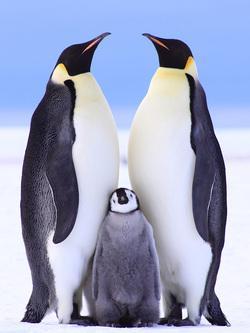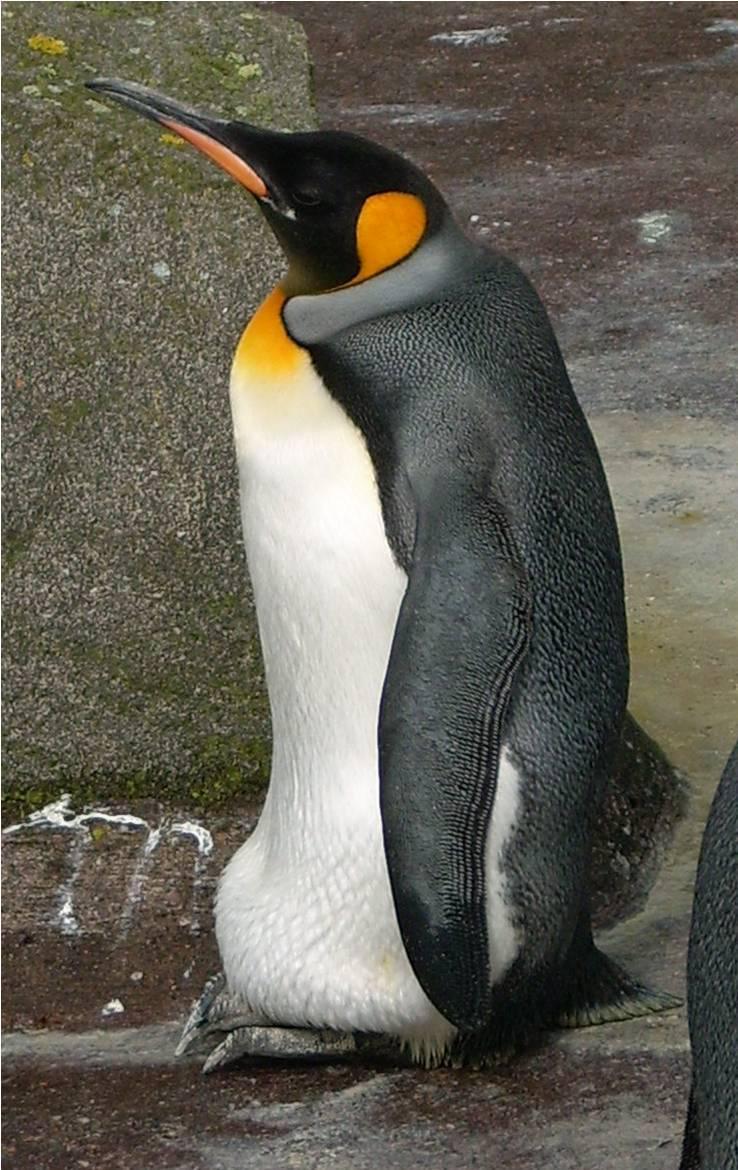The first image is the image on the left, the second image is the image on the right. Assess this claim about the two images: "There are four penguins". Correct or not? Answer yes or no. Yes. 